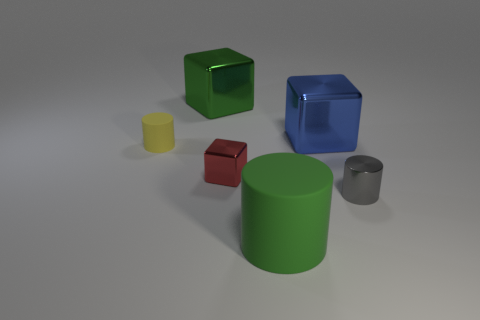Subtract all yellow cubes. Subtract all brown cylinders. How many cubes are left? 3 Add 2 tiny gray objects. How many objects exist? 8 Add 6 large yellow shiny objects. How many large yellow shiny objects exist? 6 Subtract 0 red spheres. How many objects are left? 6 Subtract all small yellow rubber cubes. Subtract all green rubber things. How many objects are left? 5 Add 4 gray objects. How many gray objects are left? 5 